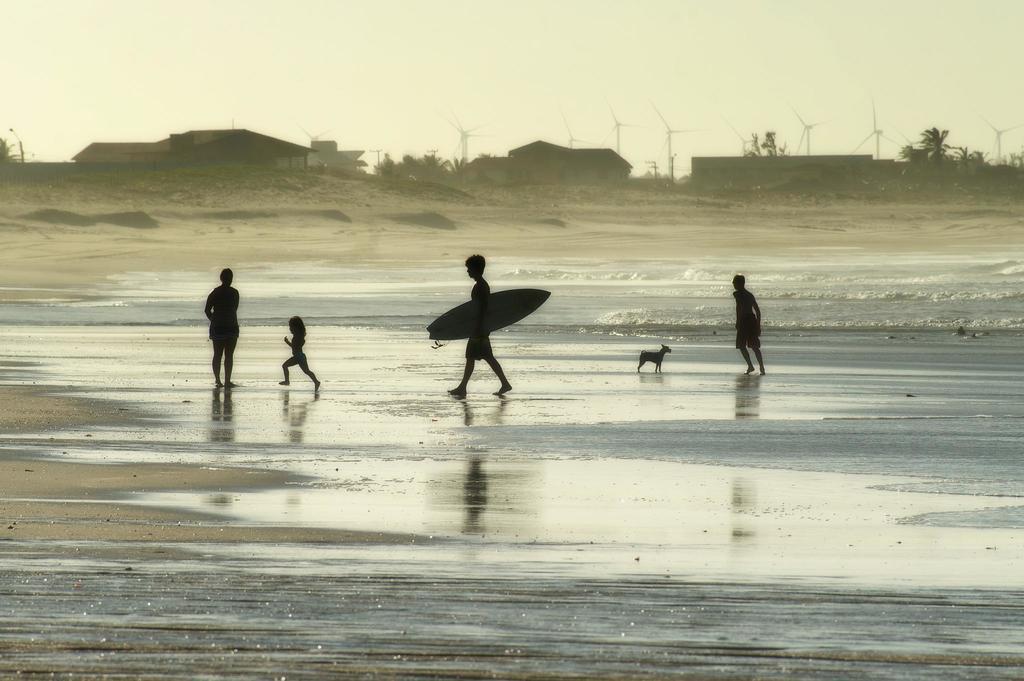Please provide a concise description of this image. On the seashore there are four persons and one dog. To the right side there is a person walking. A dog is standing in front of him. And in the middle there is a man walking holding a surfboard in his hand. In front of him there is a kid running. In front of the kid a person standing. In the background there are is a house to the left to corner. And in the middle there is a house. And to the right corner there are trees. And we can see windmills on top corner. 